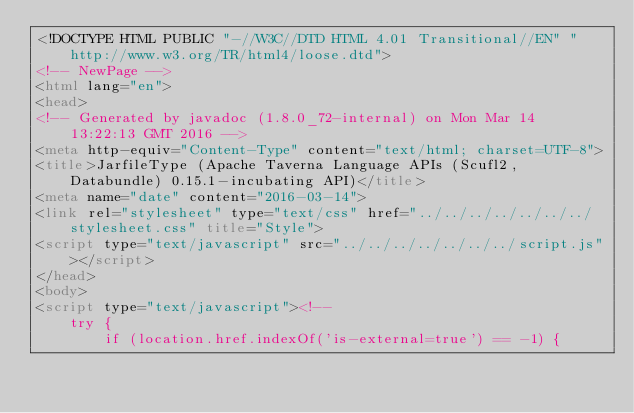<code> <loc_0><loc_0><loc_500><loc_500><_HTML_><!DOCTYPE HTML PUBLIC "-//W3C//DTD HTML 4.01 Transitional//EN" "http://www.w3.org/TR/html4/loose.dtd">
<!-- NewPage -->
<html lang="en">
<head>
<!-- Generated by javadoc (1.8.0_72-internal) on Mon Mar 14 13:22:13 GMT 2016 -->
<meta http-equiv="Content-Type" content="text/html; charset=UTF-8">
<title>JarfileType (Apache Taverna Language APIs (Scufl2, Databundle) 0.15.1-incubating API)</title>
<meta name="date" content="2016-03-14">
<link rel="stylesheet" type="text/css" href="../../../../../../../stylesheet.css" title="Style">
<script type="text/javascript" src="../../../../../../../script.js"></script>
</head>
<body>
<script type="text/javascript"><!--
    try {
        if (location.href.indexOf('is-external=true') == -1) {</code> 